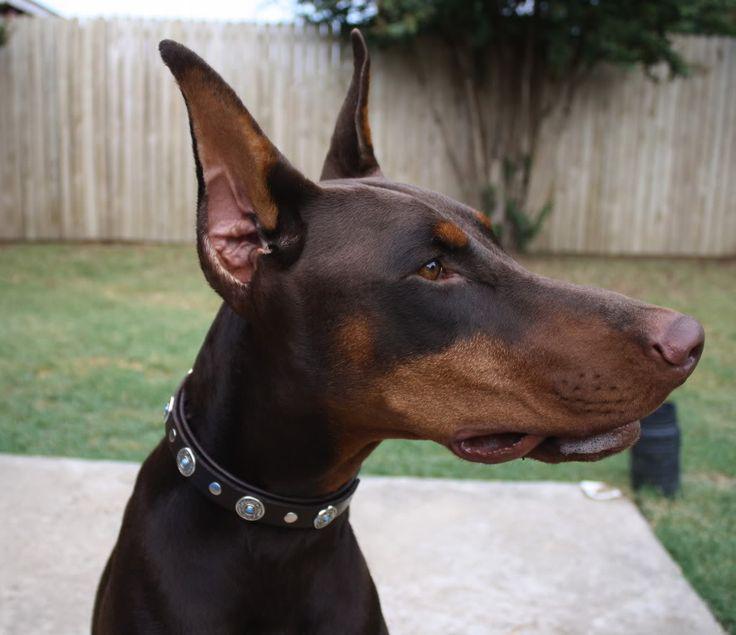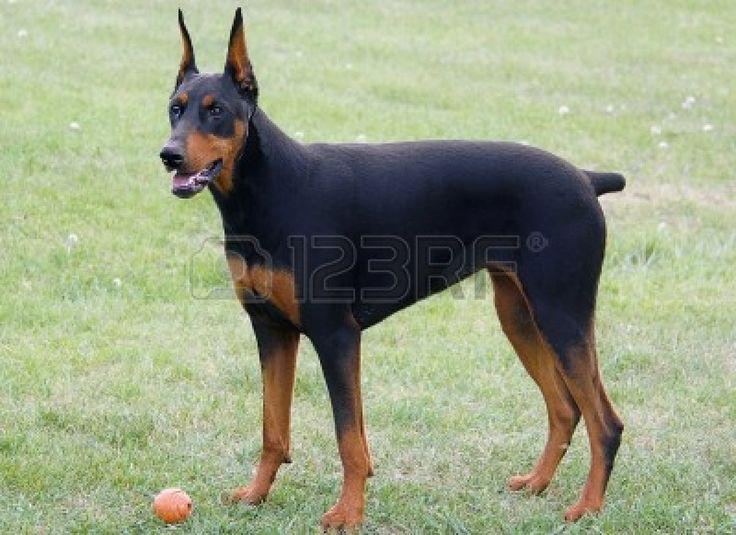The first image is the image on the left, the second image is the image on the right. Considering the images on both sides, is "The left image features a doberman in a collar with its head in profile facing right, and the right image features a dock-tailed doberman standing on all fours with body angled leftward." valid? Answer yes or no. Yes. The first image is the image on the left, the second image is the image on the right. For the images displayed, is the sentence "The left image shows a black and brown dog with its mouth open and teeth visible." factually correct? Answer yes or no. No. 